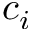<formula> <loc_0><loc_0><loc_500><loc_500>c _ { i }</formula> 